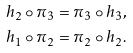<formula> <loc_0><loc_0><loc_500><loc_500>h _ { 2 } \circ \pi _ { 3 } & = \pi _ { 3 } \circ h _ { 3 } , \\ h _ { 1 } \circ \pi _ { 2 } & = \pi _ { 2 } \circ h _ { 2 } .</formula> 